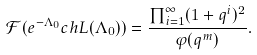Convert formula to latex. <formula><loc_0><loc_0><loc_500><loc_500>\mathcal { F } ( e ^ { - \Lambda _ { 0 } } c h L ( \Lambda _ { 0 } ) ) = \frac { \prod ^ { \infty } _ { i = 1 } ( 1 + q ^ { i } ) ^ { 2 } } { \varphi ( q ^ { m } ) } .</formula> 